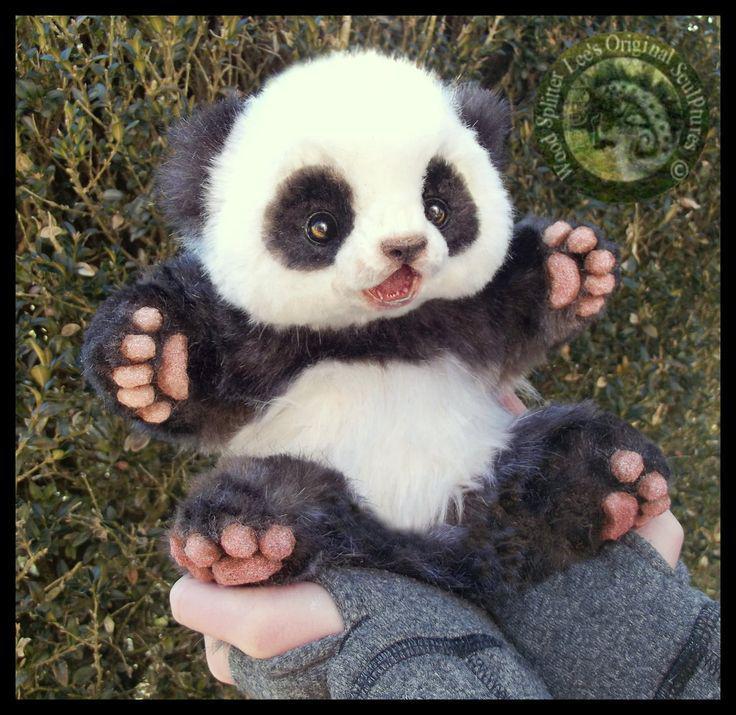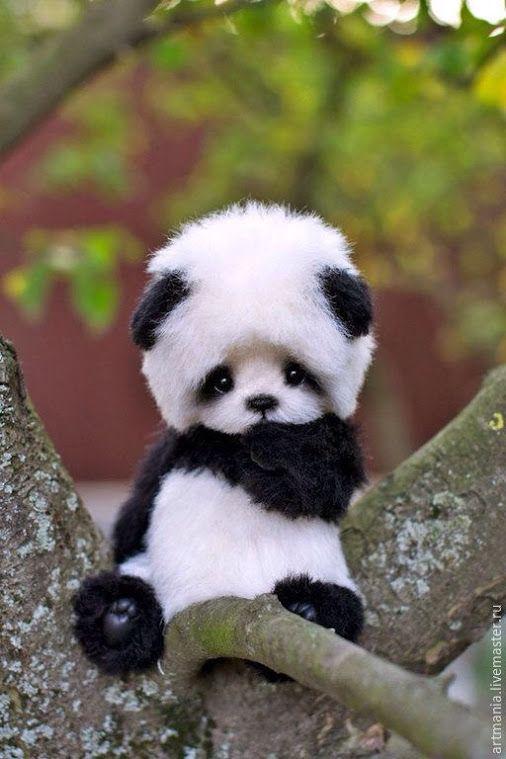The first image is the image on the left, the second image is the image on the right. Considering the images on both sides, is "At least one image shows multiple pandas piled on a flat green surface resembling a tablecloth." valid? Answer yes or no. No. The first image is the image on the left, the second image is the image on the right. Assess this claim about the two images: "Both images show only baby pandas and no adult pandas.". Correct or not? Answer yes or no. Yes. 